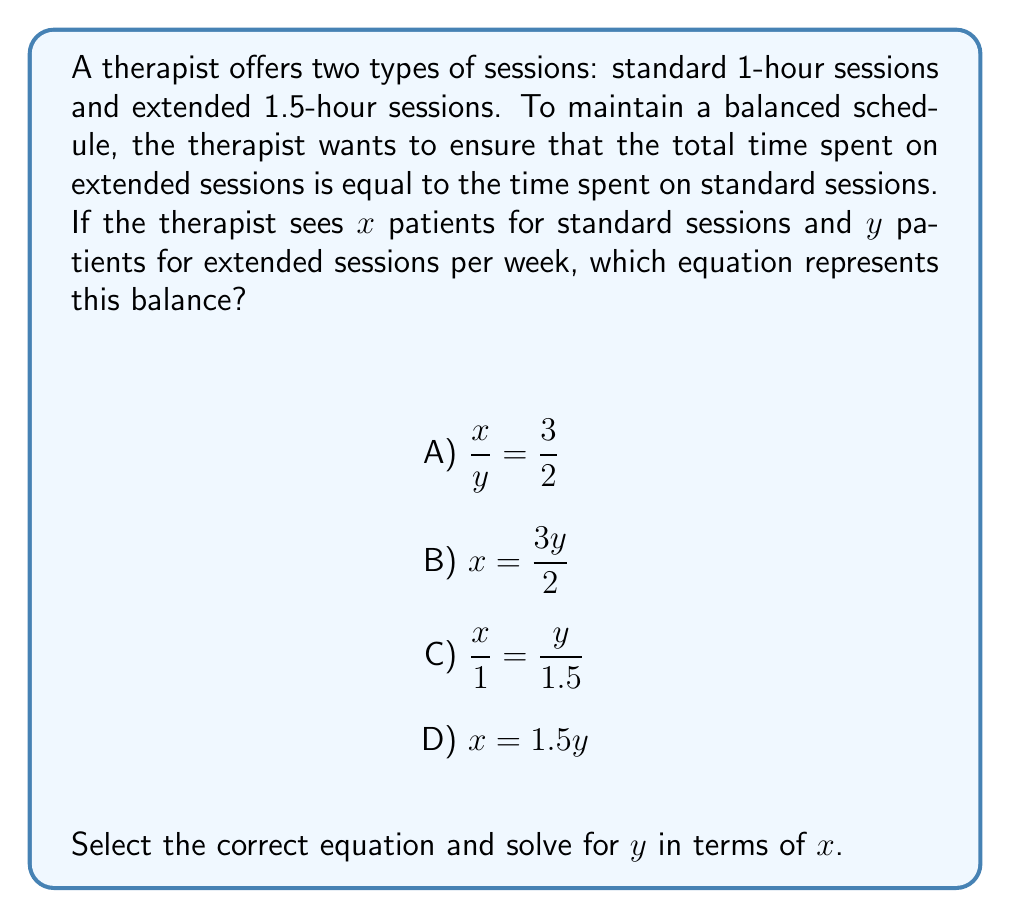Teach me how to tackle this problem. Let's approach this step-by-step:

1) First, we need to understand what each equation represents:
   A) $\frac{x}{y} = \frac{3}{2}$ - This compares the number of patients, not time.
   B) $x = \frac{3y}{2}$ - This also compares the number of patients, not time.
   C) $\frac{x}{1} = \frac{y}{1.5}$ - This compares time spent per patient type.
   D) $x = 1.5y$ - This compares the number of patients, not time.

2) The correct equation is C: $\frac{x}{1} = \frac{y}{1.5}$
   This equation balances the time spent on each type of session:
   - $x$ patients for 1 hour each
   - $y$ patients for 1.5 hours each

3) To solve for $y$ in terms of $x$, we can cross-multiply:

   $$x \cdot 1.5 = y \cdot 1$$

4) Simplify:

   $$1.5x = y$$

5) To express $y$ in terms of $x$, we don't need to change anything further.

Therefore, the final equation expressing $y$ in terms of $x$ is:

   $$y = 1.5x$$

This means that for every standard session patient, the therapist should see 1.5 extended session patients to maintain the time balance.
Answer: C) $\frac{x}{1} = \frac{y}{1.5}$; $y = 1.5x$ 